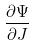Convert formula to latex. <formula><loc_0><loc_0><loc_500><loc_500>\frac { \partial \Psi } { \partial J }</formula> 